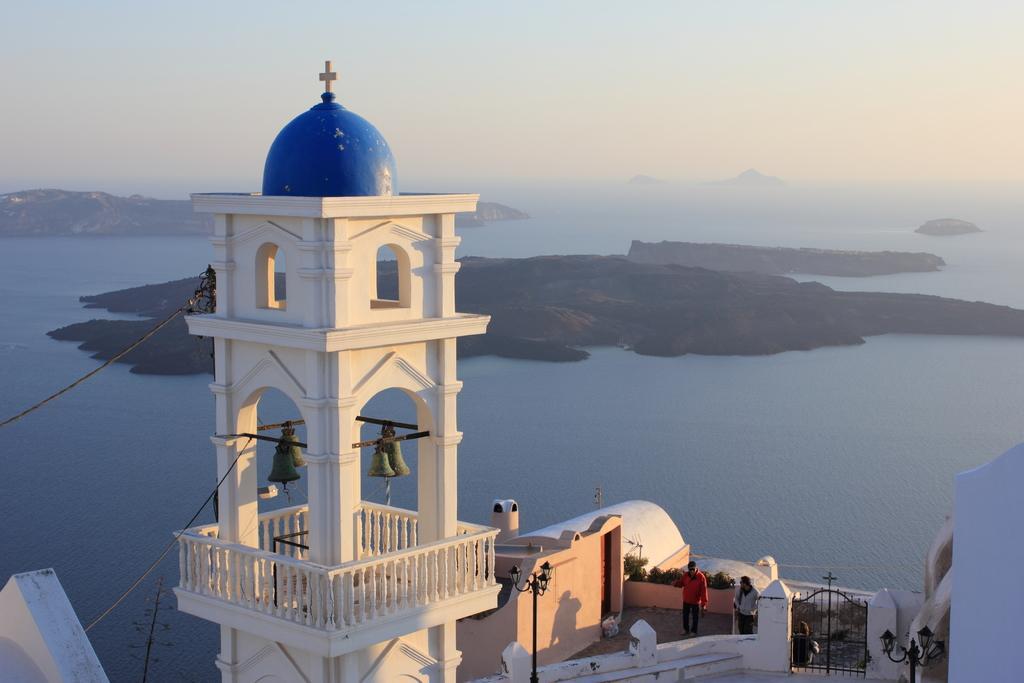Can you describe this image briefly? In the foreground of the image there is a church. There are people. In the background of the image there are mountains, water and sky. 